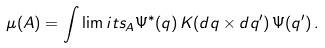Convert formula to latex. <formula><loc_0><loc_0><loc_500><loc_500>\mu ( A ) = \int \lim i t s _ { A } \Psi ^ { * } ( q ) \, K ( d q \times d q ^ { \prime } ) \, \Psi ( q ^ { \prime } ) \, .</formula> 